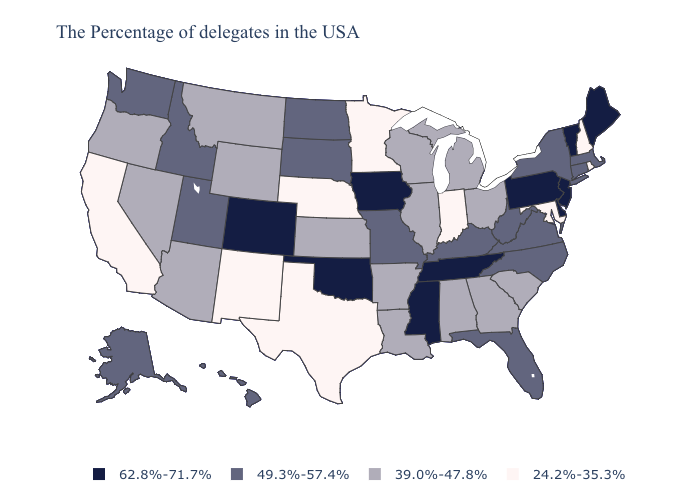Name the states that have a value in the range 24.2%-35.3%?
Keep it brief. Rhode Island, New Hampshire, Maryland, Indiana, Minnesota, Nebraska, Texas, New Mexico, California. Among the states that border Kentucky , which have the lowest value?
Short answer required. Indiana. Does Kansas have the lowest value in the USA?
Quick response, please. No. What is the value of Minnesota?
Give a very brief answer. 24.2%-35.3%. Among the states that border West Virginia , which have the lowest value?
Concise answer only. Maryland. Name the states that have a value in the range 39.0%-47.8%?
Be succinct. South Carolina, Ohio, Georgia, Michigan, Alabama, Wisconsin, Illinois, Louisiana, Arkansas, Kansas, Wyoming, Montana, Arizona, Nevada, Oregon. Among the states that border Alabama , does Florida have the highest value?
Keep it brief. No. What is the value of Iowa?
Give a very brief answer. 62.8%-71.7%. What is the value of Arkansas?
Keep it brief. 39.0%-47.8%. Name the states that have a value in the range 39.0%-47.8%?
Quick response, please. South Carolina, Ohio, Georgia, Michigan, Alabama, Wisconsin, Illinois, Louisiana, Arkansas, Kansas, Wyoming, Montana, Arizona, Nevada, Oregon. What is the value of Kansas?
Keep it brief. 39.0%-47.8%. How many symbols are there in the legend?
Give a very brief answer. 4. Name the states that have a value in the range 62.8%-71.7%?
Give a very brief answer. Maine, Vermont, New Jersey, Delaware, Pennsylvania, Tennessee, Mississippi, Iowa, Oklahoma, Colorado. Name the states that have a value in the range 39.0%-47.8%?
Keep it brief. South Carolina, Ohio, Georgia, Michigan, Alabama, Wisconsin, Illinois, Louisiana, Arkansas, Kansas, Wyoming, Montana, Arizona, Nevada, Oregon. What is the lowest value in the USA?
Concise answer only. 24.2%-35.3%. 